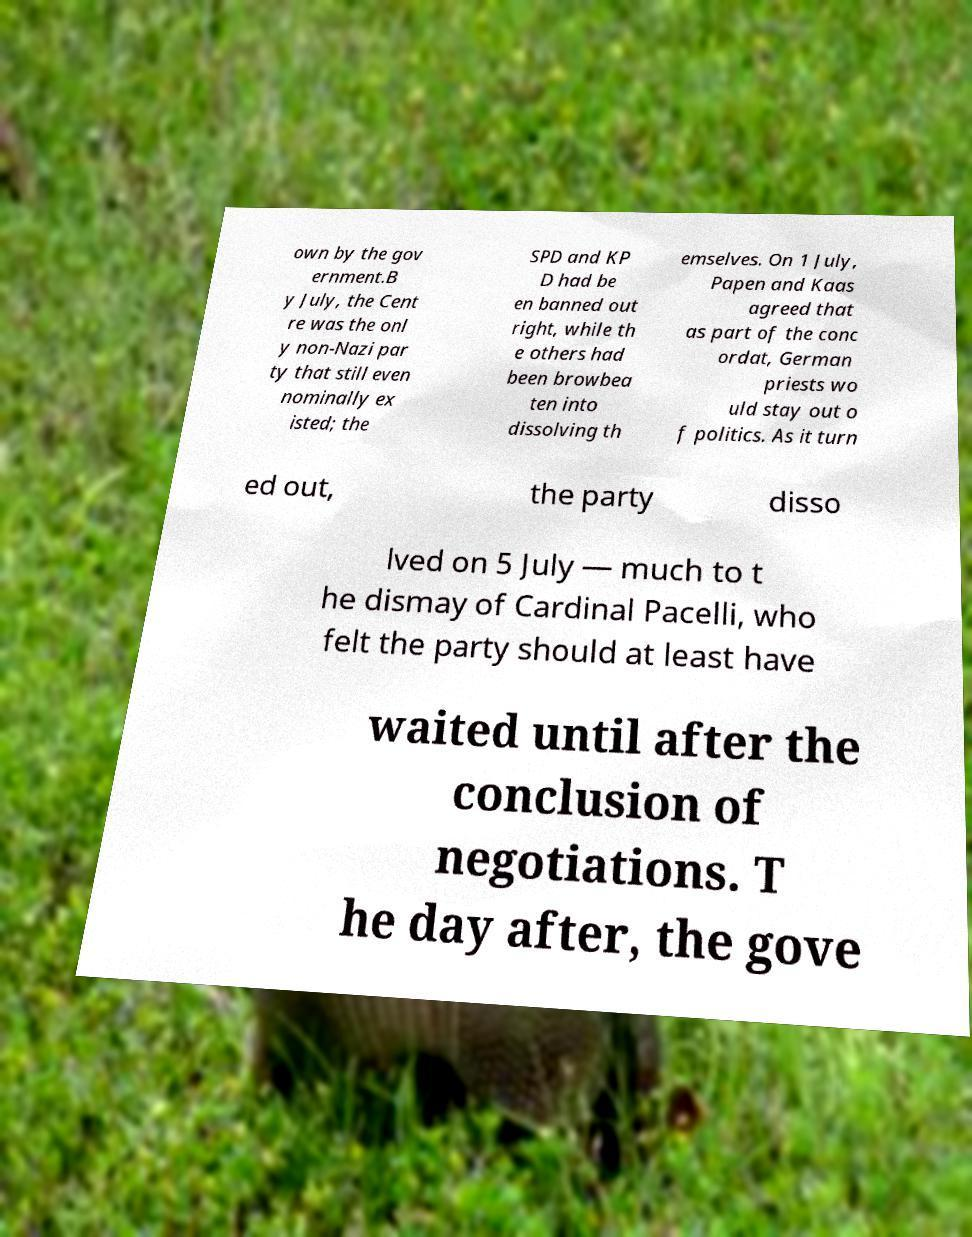There's text embedded in this image that I need extracted. Can you transcribe it verbatim? own by the gov ernment.B y July, the Cent re was the onl y non-Nazi par ty that still even nominally ex isted; the SPD and KP D had be en banned out right, while th e others had been browbea ten into dissolving th emselves. On 1 July, Papen and Kaas agreed that as part of the conc ordat, German priests wo uld stay out o f politics. As it turn ed out, the party disso lved on 5 July — much to t he dismay of Cardinal Pacelli, who felt the party should at least have waited until after the conclusion of negotiations. T he day after, the gove 